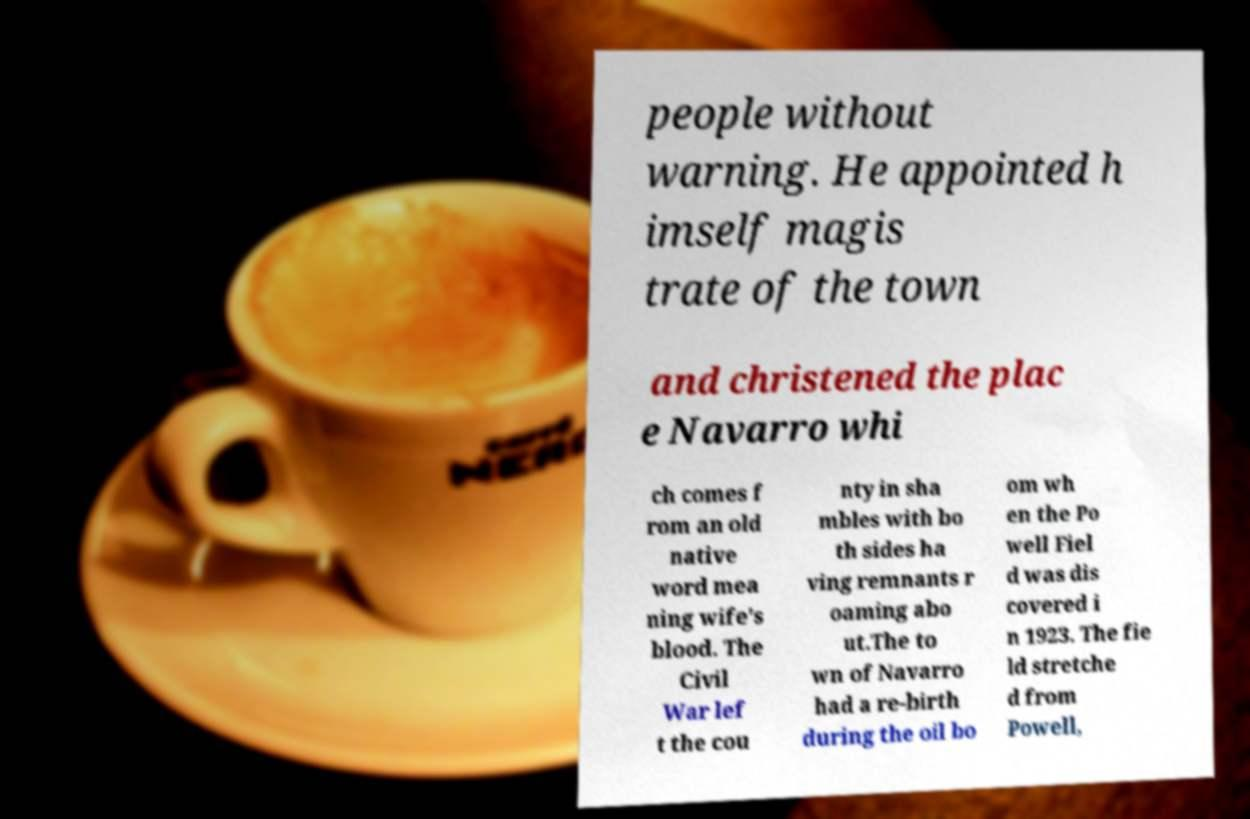Could you extract and type out the text from this image? people without warning. He appointed h imself magis trate of the town and christened the plac e Navarro whi ch comes f rom an old native word mea ning wife's blood. The Civil War lef t the cou nty in sha mbles with bo th sides ha ving remnants r oaming abo ut.The to wn of Navarro had a re-birth during the oil bo om wh en the Po well Fiel d was dis covered i n 1923. The fie ld stretche d from Powell, 